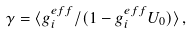<formula> <loc_0><loc_0><loc_500><loc_500>\gamma = \langle g _ { i } ^ { e f f } / ( 1 - g _ { i } ^ { e f f } U _ { 0 } ) \rangle \, ,</formula> 